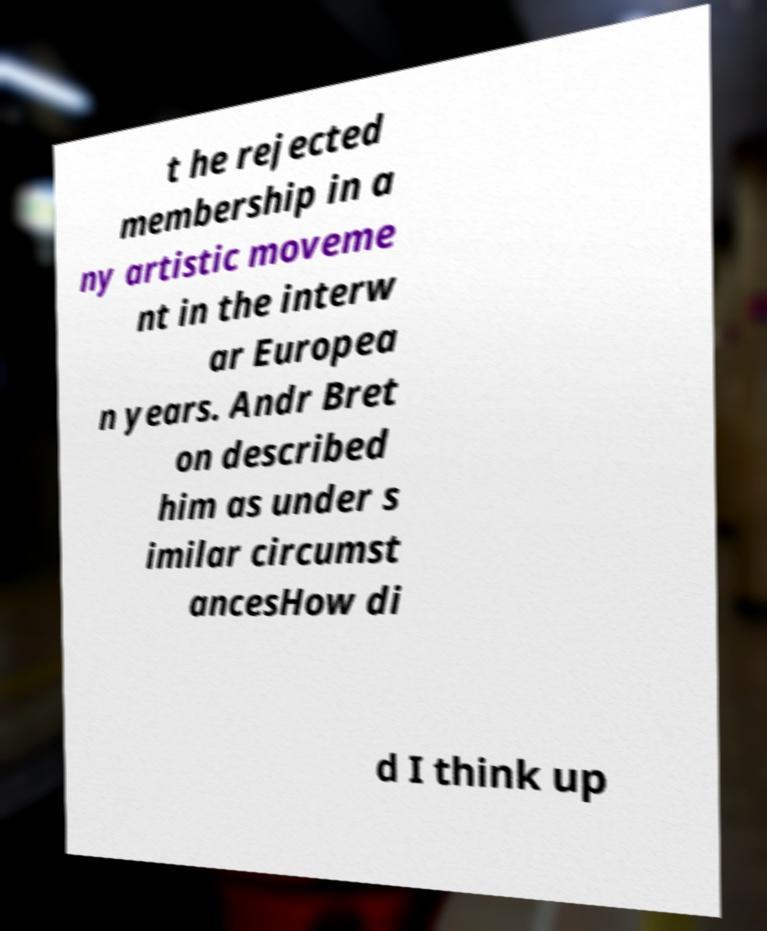Could you extract and type out the text from this image? t he rejected membership in a ny artistic moveme nt in the interw ar Europea n years. Andr Bret on described him as under s imilar circumst ancesHow di d I think up 